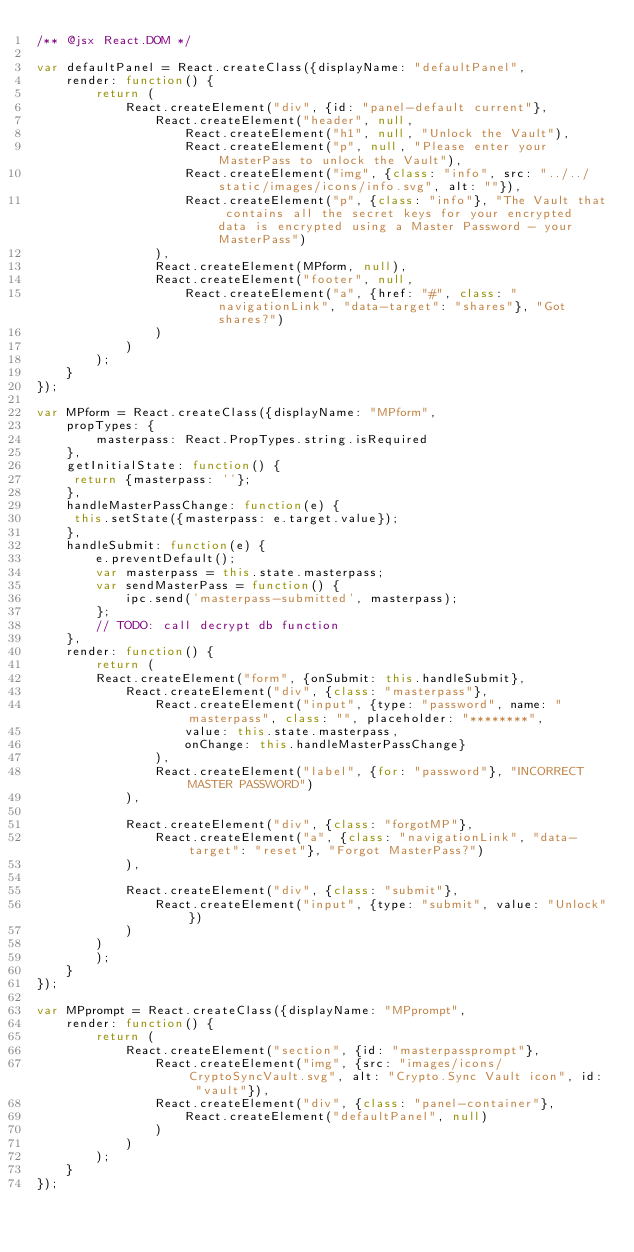<code> <loc_0><loc_0><loc_500><loc_500><_JavaScript_>/** @jsx React.DOM */

var defaultPanel = React.createClass({displayName: "defaultPanel",
	render: function() {
		return (
			React.createElement("div", {id: "panel-default current"}, 
				React.createElement("header", null, 
					React.createElement("h1", null, "Unlock the Vault"), 
					React.createElement("p", null, "Please enter your MasterPass to unlock the Vault"), 
					React.createElement("img", {class: "info", src: "../../static/images/icons/info.svg", alt: ""}), 
					React.createElement("p", {class: "info"}, "The Vault that contains all the secret keys for your encrypted data is encrypted using a Master Password - your MasterPass")
				), 
				React.createElement(MPform, null), 
				React.createElement("footer", null, 
					React.createElement("a", {href: "#", class: "navigationLink", "data-target": "shares"}, "Got shares?")
				)
			)
		);
	}
});

var MPform = React.createClass({displayName: "MPform",
	propTypes: {
		masterpass: React.PropTypes.string.isRequired
	},
	getInitialState: function() {
	 return {masterpass: ''};
	},
	handleMasterPassChange: function(e) {
	 this.setState({masterpass: e.target.value});
	},
	handleSubmit: function(e) {
		e.preventDefault();
		var masterpass = this.state.masterpass;
		var sendMasterPass = function() {
			ipc.send('masterpass-submitted', masterpass);
		};
		// TODO: call decrypt db function
	},
	render: function() {
		return (
		React.createElement("form", {onSubmit: this.handleSubmit}, 
			React.createElement("div", {class: "masterpass"}, 
				React.createElement("input", {type: "password", name: "masterpass", class: "", placeholder: "********", 
					value: this.state.masterpass, 
					onChange: this.handleMasterPassChange}
				), 
				React.createElement("label", {for: "password"}, "INCORRECT MASTER PASSWORD")
			), 

			React.createElement("div", {class: "forgotMP"}, 
				React.createElement("a", {class: "navigationLink", "data-target": "reset"}, "Forgot MasterPass?")
			), 

			React.createElement("div", {class: "submit"}, 
				React.createElement("input", {type: "submit", value: "Unlock"})
			)
		)
		);
	}
});

var MPprompt = React.createClass({displayName: "MPprompt",
	render: function() {
		return (
			React.createElement("section", {id: "masterpassprompt"}, 
				React.createElement("img", {src: "images/icons/CryptoSyncVault.svg", alt: "Crypto.Sync Vault icon", id: "vault"}), 
				React.createElement("div", {class: "panel-container"}, 
					React.createElement("defaultPanel", null)
				)
			)
		);
	}
});</code> 